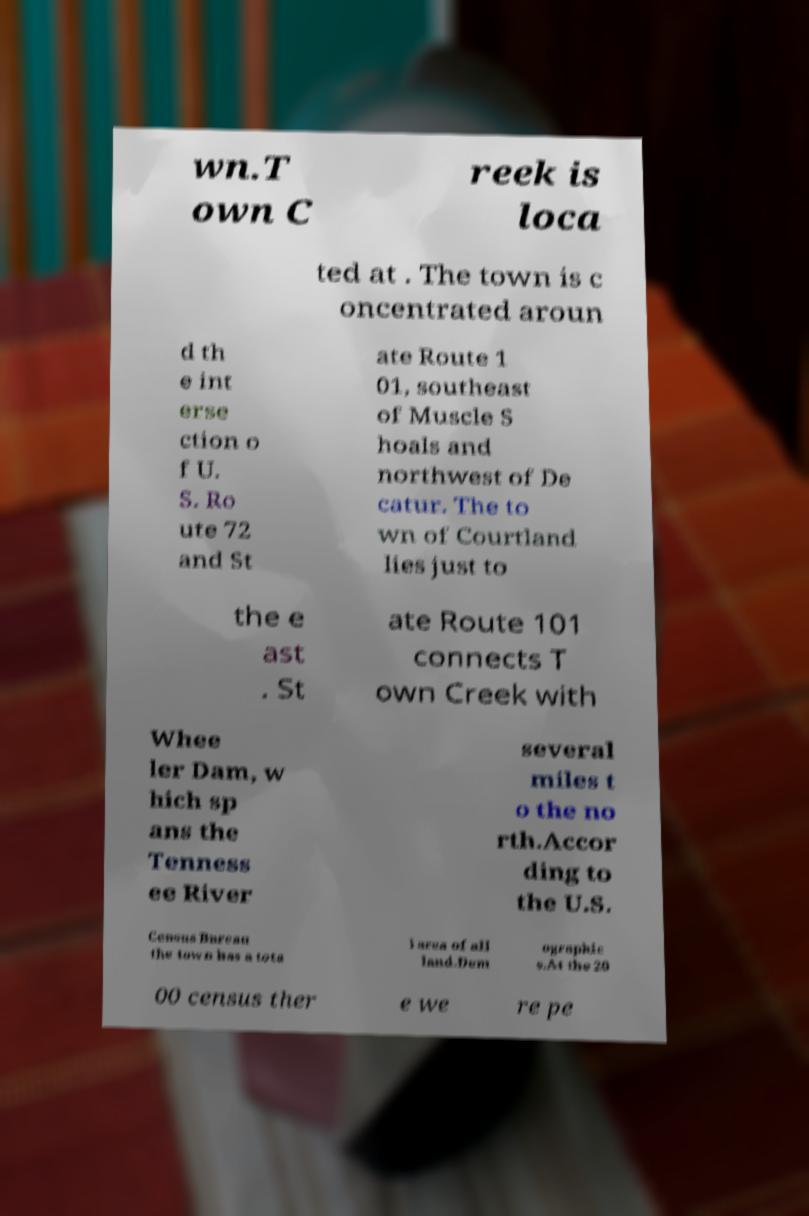There's text embedded in this image that I need extracted. Can you transcribe it verbatim? wn.T own C reek is loca ted at . The town is c oncentrated aroun d th e int erse ction o f U. S. Ro ute 72 and St ate Route 1 01, southeast of Muscle S hoals and northwest of De catur. The to wn of Courtland lies just to the e ast . St ate Route 101 connects T own Creek with Whee ler Dam, w hich sp ans the Tenness ee River several miles t o the no rth.Accor ding to the U.S. Census Bureau the town has a tota l area of all land.Dem ographic s.At the 20 00 census ther e we re pe 